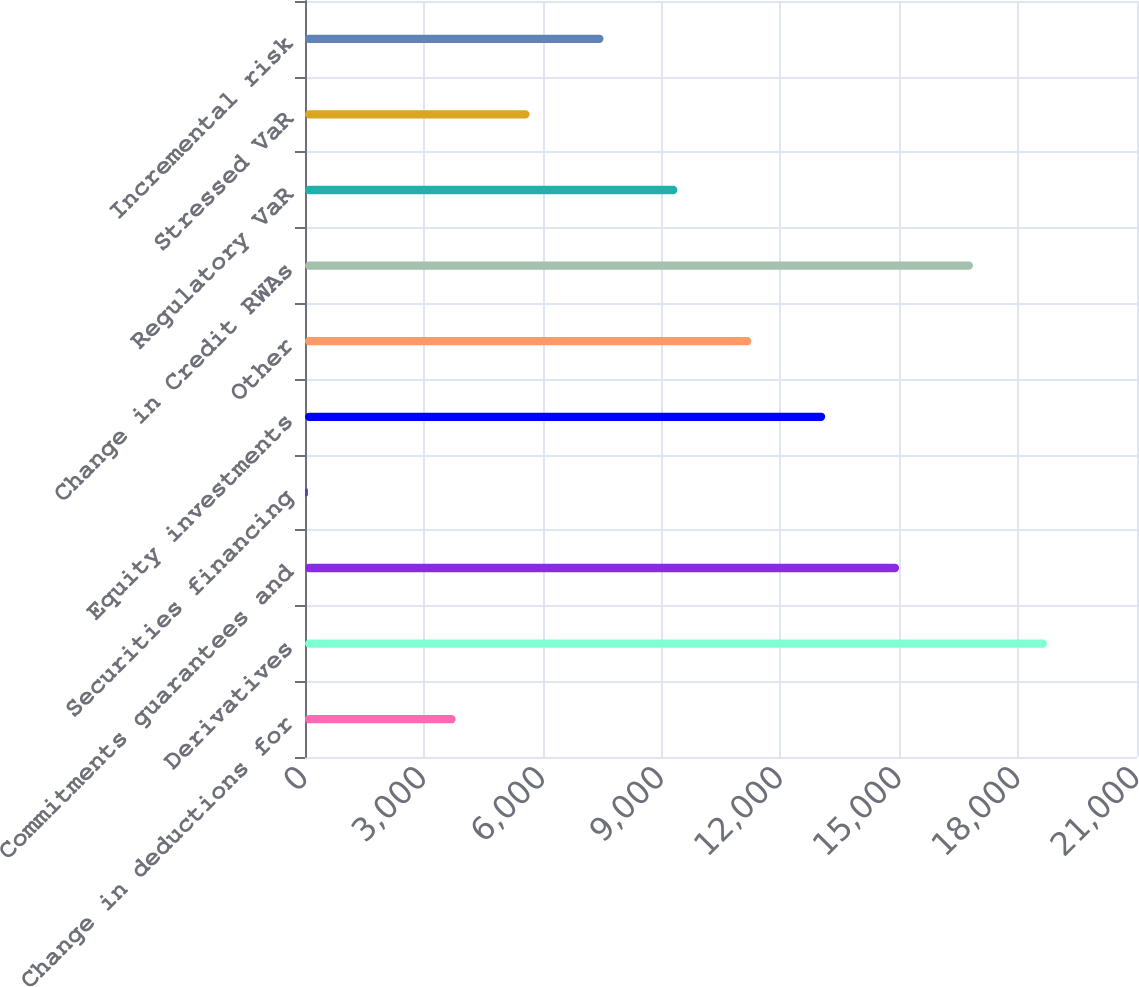Convert chart. <chart><loc_0><loc_0><loc_500><loc_500><bar_chart><fcel>Change in deductions for<fcel>Derivatives<fcel>Commitments guarantees and<fcel>Securities financing<fcel>Equity investments<fcel>Other<fcel>Change in Credit RWAs<fcel>Regulatory VaR<fcel>Stressed VaR<fcel>Incremental risk<nl><fcel>3803.6<fcel>18726<fcel>14995.4<fcel>73<fcel>13130.1<fcel>11264.8<fcel>16860.7<fcel>9399.5<fcel>5668.9<fcel>7534.2<nl></chart> 